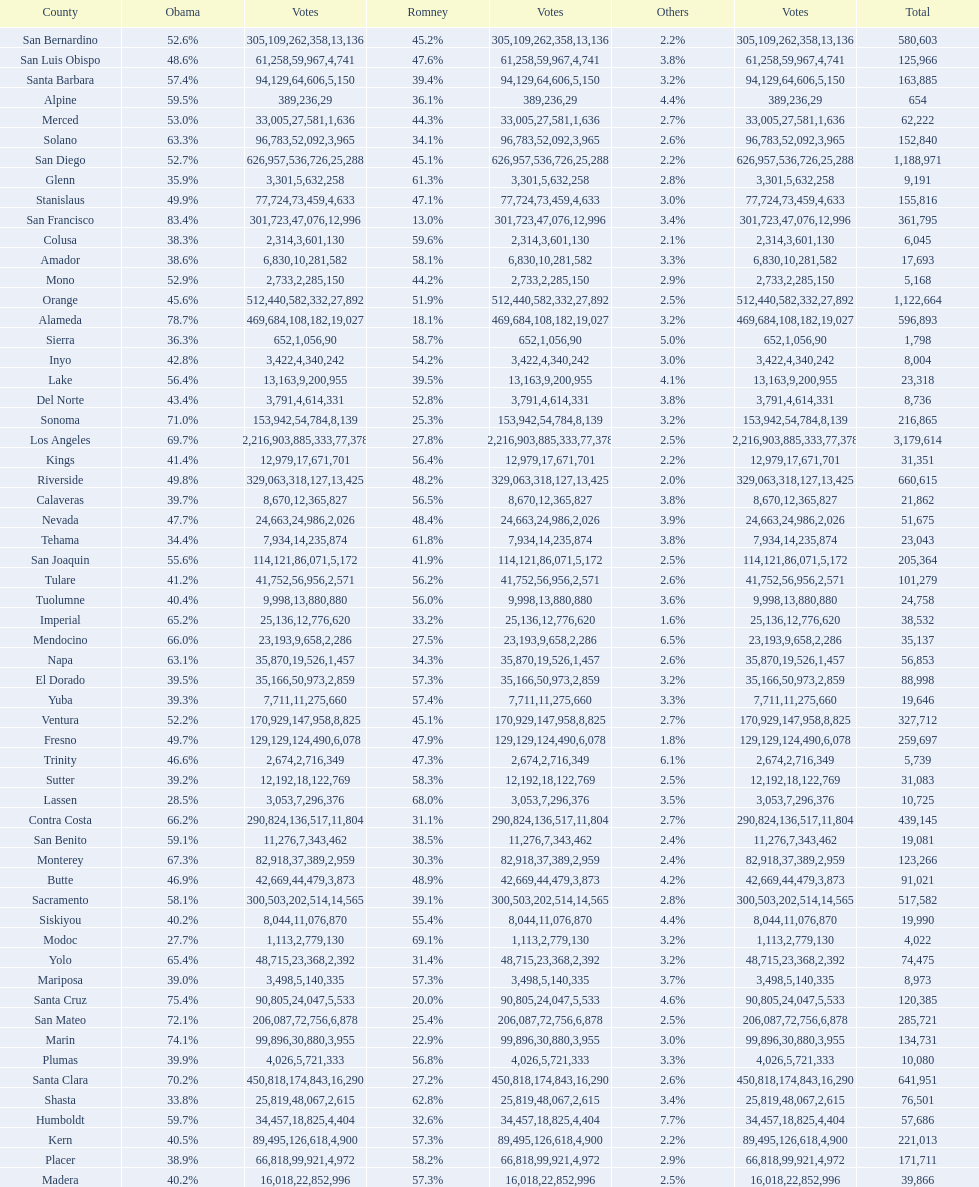Would you mind parsing the complete table? {'header': ['County', 'Obama', 'Votes', 'Romney', 'Votes', 'Others', 'Votes', 'Total'], 'rows': [['San Bernardino', '52.6%', '305,109', '45.2%', '262,358', '2.2%', '13,136', '580,603'], ['San Luis Obispo', '48.6%', '61,258', '47.6%', '59,967', '3.8%', '4,741', '125,966'], ['Santa Barbara', '57.4%', '94,129', '39.4%', '64,606', '3.2%', '5,150', '163,885'], ['Alpine', '59.5%', '389', '36.1%', '236', '4.4%', '29', '654'], ['Merced', '53.0%', '33,005', '44.3%', '27,581', '2.7%', '1,636', '62,222'], ['Solano', '63.3%', '96,783', '34.1%', '52,092', '2.6%', '3,965', '152,840'], ['San Diego', '52.7%', '626,957', '45.1%', '536,726', '2.2%', '25,288', '1,188,971'], ['Glenn', '35.9%', '3,301', '61.3%', '5,632', '2.8%', '258', '9,191'], ['Stanislaus', '49.9%', '77,724', '47.1%', '73,459', '3.0%', '4,633', '155,816'], ['San Francisco', '83.4%', '301,723', '13.0%', '47,076', '3.4%', '12,996', '361,795'], ['Colusa', '38.3%', '2,314', '59.6%', '3,601', '2.1%', '130', '6,045'], ['Amador', '38.6%', '6,830', '58.1%', '10,281', '3.3%', '582', '17,693'], ['Mono', '52.9%', '2,733', '44.2%', '2,285', '2.9%', '150', '5,168'], ['Orange', '45.6%', '512,440', '51.9%', '582,332', '2.5%', '27,892', '1,122,664'], ['Alameda', '78.7%', '469,684', '18.1%', '108,182', '3.2%', '19,027', '596,893'], ['Sierra', '36.3%', '652', '58.7%', '1,056', '5.0%', '90', '1,798'], ['Inyo', '42.8%', '3,422', '54.2%', '4,340', '3.0%', '242', '8,004'], ['Lake', '56.4%', '13,163', '39.5%', '9,200', '4.1%', '955', '23,318'], ['Del Norte', '43.4%', '3,791', '52.8%', '4,614', '3.8%', '331', '8,736'], ['Sonoma', '71.0%', '153,942', '25.3%', '54,784', '3.2%', '8,139', '216,865'], ['Los Angeles', '69.7%', '2,216,903', '27.8%', '885,333', '2.5%', '77,378', '3,179,614'], ['Kings', '41.4%', '12,979', '56.4%', '17,671', '2.2%', '701', '31,351'], ['Riverside', '49.8%', '329,063', '48.2%', '318,127', '2.0%', '13,425', '660,615'], ['Calaveras', '39.7%', '8,670', '56.5%', '12,365', '3.8%', '827', '21,862'], ['Nevada', '47.7%', '24,663', '48.4%', '24,986', '3.9%', '2,026', '51,675'], ['Tehama', '34.4%', '7,934', '61.8%', '14,235', '3.8%', '874', '23,043'], ['San Joaquin', '55.6%', '114,121', '41.9%', '86,071', '2.5%', '5,172', '205,364'], ['Tulare', '41.2%', '41,752', '56.2%', '56,956', '2.6%', '2,571', '101,279'], ['Tuolumne', '40.4%', '9,998', '56.0%', '13,880', '3.6%', '880', '24,758'], ['Imperial', '65.2%', '25,136', '33.2%', '12,776', '1.6%', '620', '38,532'], ['Mendocino', '66.0%', '23,193', '27.5%', '9,658', '6.5%', '2,286', '35,137'], ['Napa', '63.1%', '35,870', '34.3%', '19,526', '2.6%', '1,457', '56,853'], ['El Dorado', '39.5%', '35,166', '57.3%', '50,973', '3.2%', '2,859', '88,998'], ['Yuba', '39.3%', '7,711', '57.4%', '11,275', '3.3%', '660', '19,646'], ['Ventura', '52.2%', '170,929', '45.1%', '147,958', '2.7%', '8,825', '327,712'], ['Fresno', '49.7%', '129,129', '47.9%', '124,490', '1.8%', '6,078', '259,697'], ['Trinity', '46.6%', '2,674', '47.3%', '2,716', '6.1%', '349', '5,739'], ['Sutter', '39.2%', '12,192', '58.3%', '18,122', '2.5%', '769', '31,083'], ['Lassen', '28.5%', '3,053', '68.0%', '7,296', '3.5%', '376', '10,725'], ['Contra Costa', '66.2%', '290,824', '31.1%', '136,517', '2.7%', '11,804', '439,145'], ['San Benito', '59.1%', '11,276', '38.5%', '7,343', '2.4%', '462', '19,081'], ['Monterey', '67.3%', '82,918', '30.3%', '37,389', '2.4%', '2,959', '123,266'], ['Butte', '46.9%', '42,669', '48.9%', '44,479', '4.2%', '3,873', '91,021'], ['Sacramento', '58.1%', '300,503', '39.1%', '202,514', '2.8%', '14,565', '517,582'], ['Siskiyou', '40.2%', '8,044', '55.4%', '11,076', '4.4%', '870', '19,990'], ['Modoc', '27.7%', '1,113', '69.1%', '2,779', '3.2%', '130', '4,022'], ['Yolo', '65.4%', '48,715', '31.4%', '23,368', '3.2%', '2,392', '74,475'], ['Mariposa', '39.0%', '3,498', '57.3%', '5,140', '3.7%', '335', '8,973'], ['Santa Cruz', '75.4%', '90,805', '20.0%', '24,047', '4.6%', '5,533', '120,385'], ['San Mateo', '72.1%', '206,087', '25.4%', '72,756', '2.5%', '6,878', '285,721'], ['Marin', '74.1%', '99,896', '22.9%', '30,880', '3.0%', '3,955', '134,731'], ['Plumas', '39.9%', '4,026', '56.8%', '5,721', '3.3%', '333', '10,080'], ['Santa Clara', '70.2%', '450,818', '27.2%', '174,843', '2.6%', '16,290', '641,951'], ['Shasta', '33.8%', '25,819', '62.8%', '48,067', '3.4%', '2,615', '76,501'], ['Humboldt', '59.7%', '34,457', '32.6%', '18,825', '7.7%', '4,404', '57,686'], ['Kern', '40.5%', '89,495', '57.3%', '126,618', '2.2%', '4,900', '221,013'], ['Placer', '38.9%', '66,818', '58.2%', '99,921', '2.9%', '4,972', '171,711'], ['Madera', '40.2%', '16,018', '57.3%', '22,852', '2.5%', '996', '39,866']]} Which county had the most total votes? Los Angeles. 